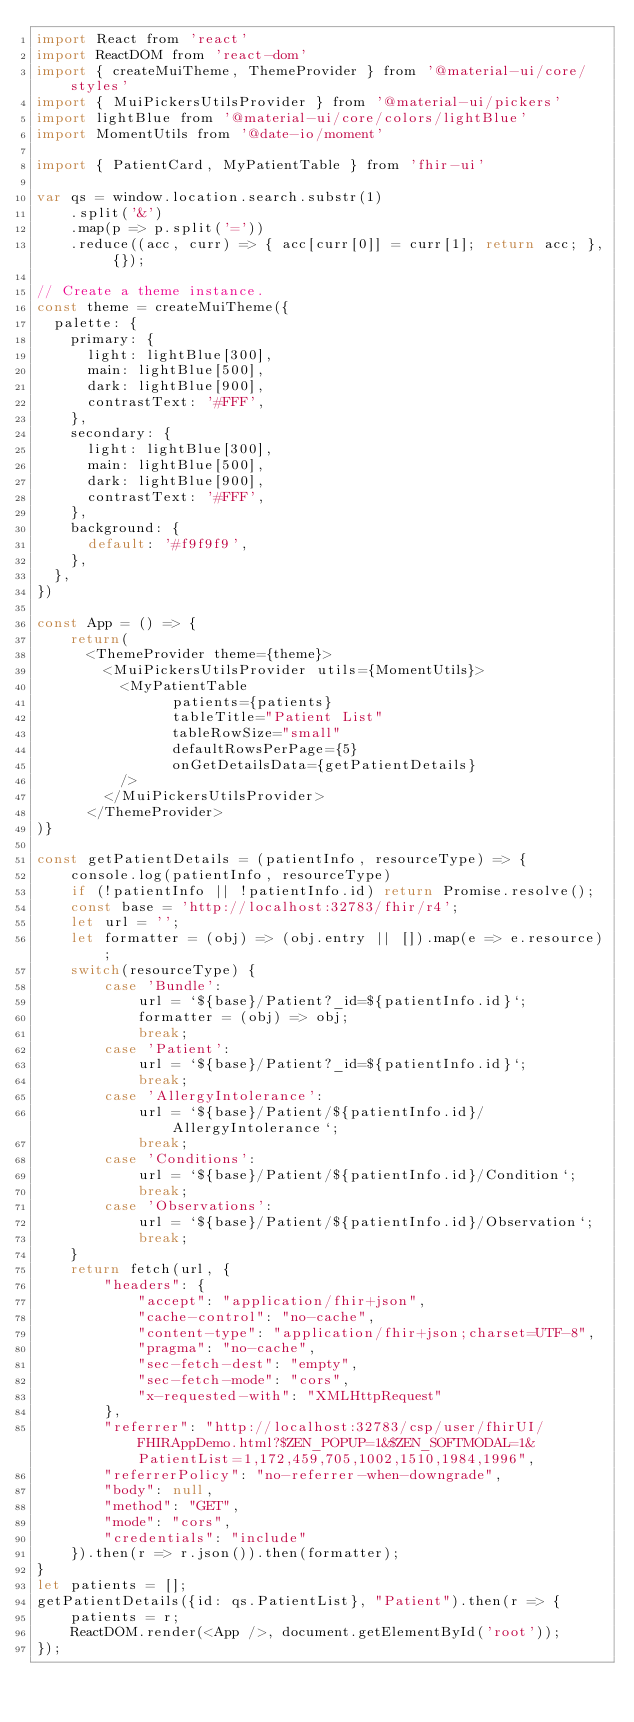Convert code to text. <code><loc_0><loc_0><loc_500><loc_500><_JavaScript_>import React from 'react'
import ReactDOM from 'react-dom'
import { createMuiTheme, ThemeProvider } from '@material-ui/core/styles'
import { MuiPickersUtilsProvider } from '@material-ui/pickers'
import lightBlue from '@material-ui/core/colors/lightBlue'
import MomentUtils from '@date-io/moment'

import { PatientCard, MyPatientTable } from 'fhir-ui'

var qs = window.location.search.substr(1)
	.split('&')
	.map(p => p.split('='))
	.reduce((acc, curr) => { acc[curr[0]] = curr[1]; return acc; }, {});

// Create a theme instance.
const theme = createMuiTheme({
  palette: {
    primary: {
      light: lightBlue[300],
      main: lightBlue[500],
      dark: lightBlue[900],
      contrastText: '#FFF',
    },
    secondary: {
      light: lightBlue[300],
      main: lightBlue[500],
      dark: lightBlue[900],
      contrastText: '#FFF',
    },
    background: {
      default: '#f9f9f9',
    },
  },
})

const App = () => {
	return(
	  <ThemeProvider theme={theme}>
		<MuiPickersUtilsProvider utils={MomentUtils}>
		  <MyPatientTable
				patients={patients}
				tableTitle="Patient List"
				tableRowSize="small"
				defaultRowsPerPage={5}
				onGetDetailsData={getPatientDetails}
		  />
		</MuiPickersUtilsProvider>
	  </ThemeProvider>
)}

const getPatientDetails = (patientInfo, resourceType) => {
	console.log(patientInfo, resourceType)
	if (!patientInfo || !patientInfo.id) return Promise.resolve();
	const base = 'http://localhost:32783/fhir/r4';
	let url = '';
	let formatter = (obj) => (obj.entry || []).map(e => e.resource);
	switch(resourceType) {
		case 'Bundle':
			url = `${base}/Patient?_id=${patientInfo.id}`;
			formatter = (obj) => obj;
			break;
		case 'Patient':
			url = `${base}/Patient?_id=${patientInfo.id}`;
			break;
		case 'AllergyIntolerance':
			url = `${base}/Patient/${patientInfo.id}/AllergyIntolerance`;
			break;
		case 'Conditions':
			url = `${base}/Patient/${patientInfo.id}/Condition`;
			break;
		case 'Observations':
			url = `${base}/Patient/${patientInfo.id}/Observation`;
			break;
	}
	return fetch(url, {
		"headers": {
			"accept": "application/fhir+json",
			"cache-control": "no-cache",
			"content-type": "application/fhir+json;charset=UTF-8",
			"pragma": "no-cache",
			"sec-fetch-dest": "empty",
			"sec-fetch-mode": "cors",
			"x-requested-with": "XMLHttpRequest"
		},
		"referrer": "http://localhost:32783/csp/user/fhirUI/FHIRAppDemo.html?$ZEN_POPUP=1&$ZEN_SOFTMODAL=1&PatientList=1,172,459,705,1002,1510,1984,1996",
		"referrerPolicy": "no-referrer-when-downgrade",
		"body": null,
		"method": "GET",
		"mode": "cors",
		"credentials": "include"
	}).then(r => r.json()).then(formatter);
}
let patients = [];
getPatientDetails({id: qs.PatientList}, "Patient").then(r => {
	patients = r;
	ReactDOM.render(<App />, document.getElementById('root'));
});
</code> 